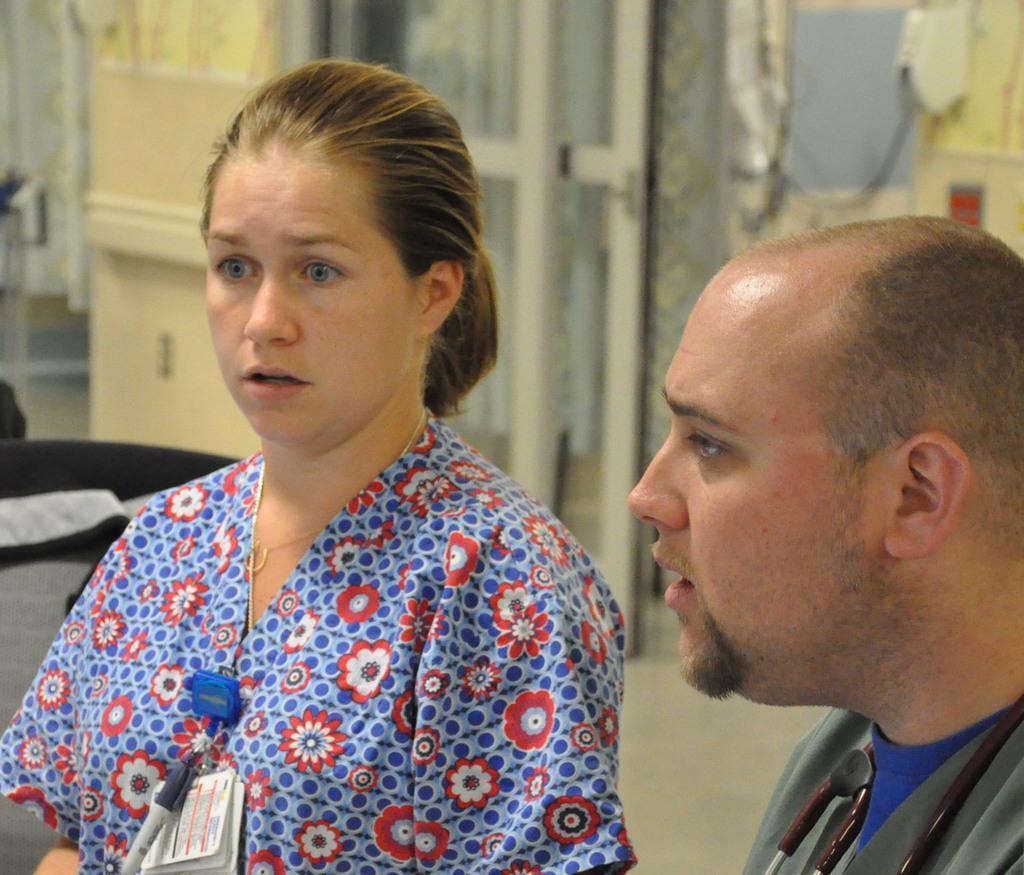How would you summarize this image in a sentence or two? Here there is a man and a woman wearing clothes. 